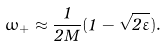<formula> <loc_0><loc_0><loc_500><loc_500>\omega _ { + } \approx \frac { 1 } { 2 M } ( 1 - \sqrt { 2 \varepsilon } ) .</formula> 